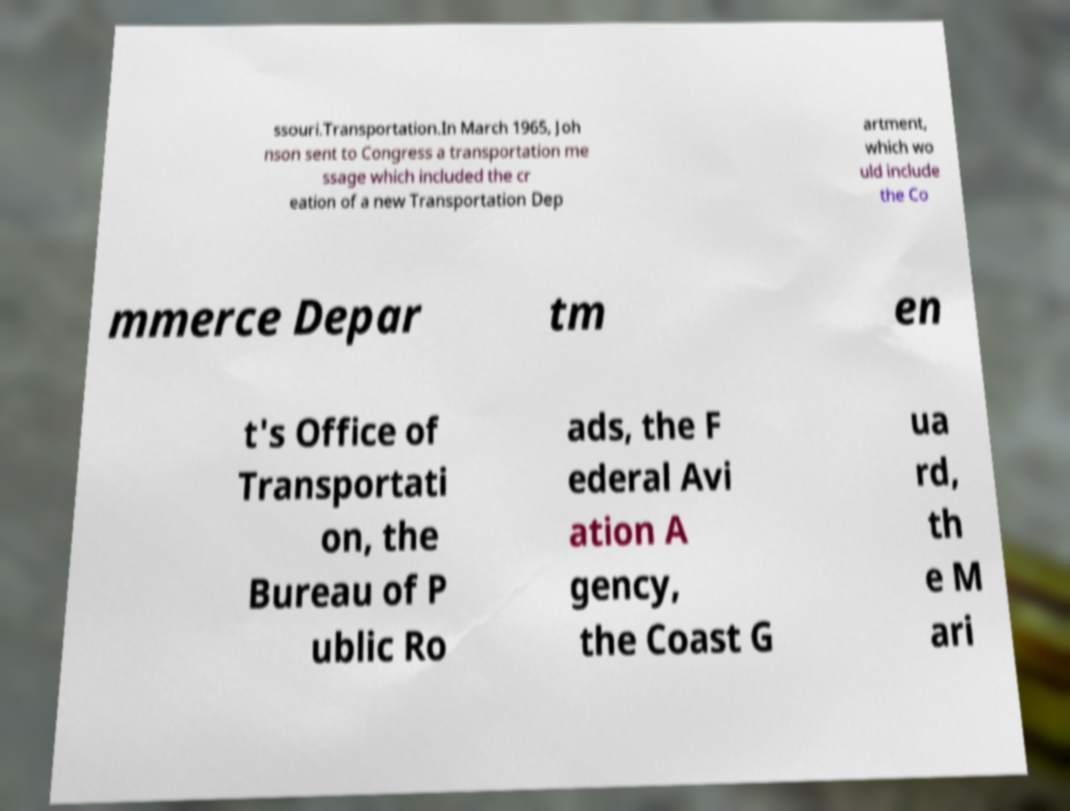Could you extract and type out the text from this image? ssouri.Transportation.In March 1965, Joh nson sent to Congress a transportation me ssage which included the cr eation of a new Transportation Dep artment, which wo uld include the Co mmerce Depar tm en t's Office of Transportati on, the Bureau of P ublic Ro ads, the F ederal Avi ation A gency, the Coast G ua rd, th e M ari 